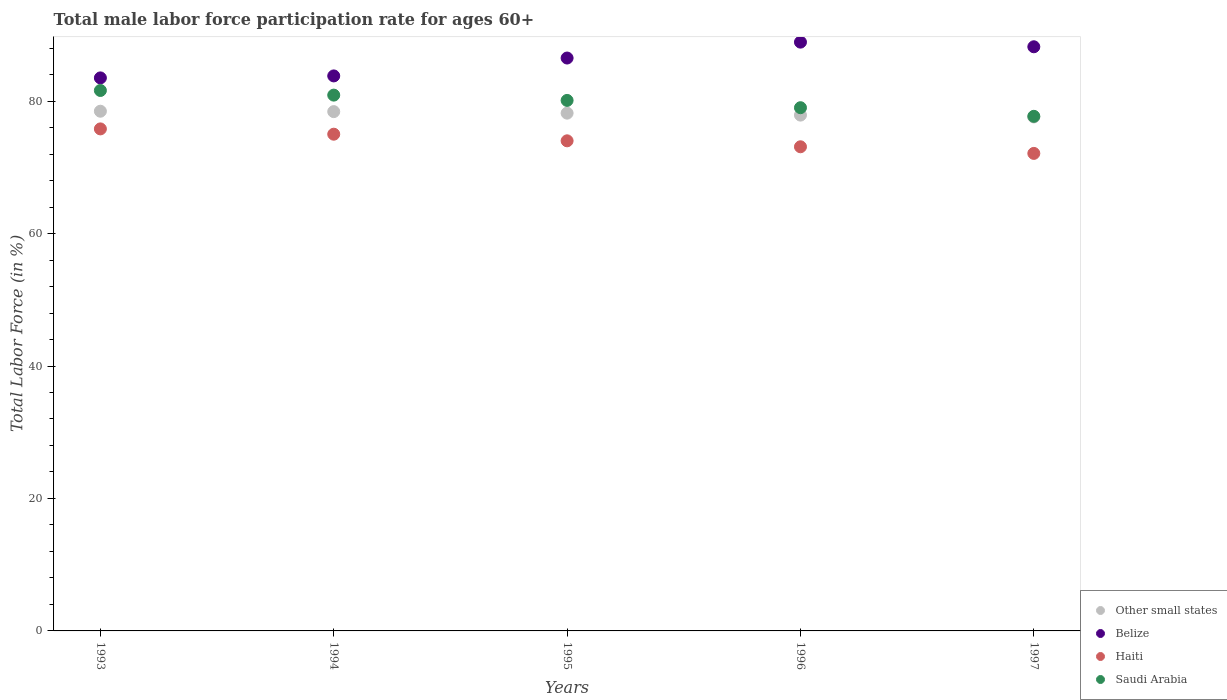What is the male labor force participation rate in Saudi Arabia in 1993?
Offer a terse response. 81.6. Across all years, what is the maximum male labor force participation rate in Belize?
Ensure brevity in your answer.  88.9. Across all years, what is the minimum male labor force participation rate in Saudi Arabia?
Your response must be concise. 77.7. In which year was the male labor force participation rate in Other small states minimum?
Your response must be concise. 1997. What is the total male labor force participation rate in Haiti in the graph?
Your answer should be compact. 370. What is the difference between the male labor force participation rate in Saudi Arabia in 1993 and that in 1997?
Offer a terse response. 3.9. What is the difference between the male labor force participation rate in Saudi Arabia in 1993 and the male labor force participation rate in Belize in 1994?
Your answer should be compact. -2.2. What is the average male labor force participation rate in Belize per year?
Ensure brevity in your answer.  86.18. In the year 1994, what is the difference between the male labor force participation rate in Belize and male labor force participation rate in Saudi Arabia?
Your response must be concise. 2.9. What is the ratio of the male labor force participation rate in Other small states in 1995 to that in 1997?
Keep it short and to the point. 1.01. Is the male labor force participation rate in Belize in 1994 less than that in 1995?
Your response must be concise. Yes. Is the difference between the male labor force participation rate in Belize in 1993 and 1995 greater than the difference between the male labor force participation rate in Saudi Arabia in 1993 and 1995?
Provide a short and direct response. No. What is the difference between the highest and the second highest male labor force participation rate in Belize?
Your response must be concise. 0.7. What is the difference between the highest and the lowest male labor force participation rate in Saudi Arabia?
Provide a succinct answer. 3.9. In how many years, is the male labor force participation rate in Belize greater than the average male labor force participation rate in Belize taken over all years?
Your answer should be very brief. 3. Is the sum of the male labor force participation rate in Saudi Arabia in 1993 and 1996 greater than the maximum male labor force participation rate in Haiti across all years?
Your answer should be compact. Yes. Is it the case that in every year, the sum of the male labor force participation rate in Haiti and male labor force participation rate in Saudi Arabia  is greater than the sum of male labor force participation rate in Belize and male labor force participation rate in Other small states?
Ensure brevity in your answer.  No. Is the male labor force participation rate in Saudi Arabia strictly less than the male labor force participation rate in Other small states over the years?
Make the answer very short. No. How many dotlines are there?
Offer a terse response. 4. Does the graph contain any zero values?
Offer a terse response. No. Does the graph contain grids?
Offer a terse response. No. Where does the legend appear in the graph?
Provide a succinct answer. Bottom right. How many legend labels are there?
Ensure brevity in your answer.  4. What is the title of the graph?
Ensure brevity in your answer.  Total male labor force participation rate for ages 60+. Does "Tuvalu" appear as one of the legend labels in the graph?
Offer a very short reply. No. What is the label or title of the X-axis?
Your answer should be compact. Years. What is the Total Labor Force (in %) of Other small states in 1993?
Your answer should be very brief. 78.47. What is the Total Labor Force (in %) of Belize in 1993?
Your answer should be compact. 83.5. What is the Total Labor Force (in %) of Haiti in 1993?
Offer a terse response. 75.8. What is the Total Labor Force (in %) of Saudi Arabia in 1993?
Make the answer very short. 81.6. What is the Total Labor Force (in %) of Other small states in 1994?
Offer a very short reply. 78.41. What is the Total Labor Force (in %) of Belize in 1994?
Your response must be concise. 83.8. What is the Total Labor Force (in %) of Saudi Arabia in 1994?
Provide a short and direct response. 80.9. What is the Total Labor Force (in %) of Other small states in 1995?
Give a very brief answer. 78.18. What is the Total Labor Force (in %) in Belize in 1995?
Offer a very short reply. 86.5. What is the Total Labor Force (in %) of Haiti in 1995?
Provide a short and direct response. 74. What is the Total Labor Force (in %) of Saudi Arabia in 1995?
Your answer should be compact. 80.1. What is the Total Labor Force (in %) in Other small states in 1996?
Provide a short and direct response. 77.88. What is the Total Labor Force (in %) of Belize in 1996?
Offer a terse response. 88.9. What is the Total Labor Force (in %) in Haiti in 1996?
Your response must be concise. 73.1. What is the Total Labor Force (in %) in Saudi Arabia in 1996?
Offer a very short reply. 79. What is the Total Labor Force (in %) of Other small states in 1997?
Offer a very short reply. 77.6. What is the Total Labor Force (in %) in Belize in 1997?
Make the answer very short. 88.2. What is the Total Labor Force (in %) of Haiti in 1997?
Your response must be concise. 72.1. What is the Total Labor Force (in %) in Saudi Arabia in 1997?
Offer a terse response. 77.7. Across all years, what is the maximum Total Labor Force (in %) in Other small states?
Offer a terse response. 78.47. Across all years, what is the maximum Total Labor Force (in %) in Belize?
Ensure brevity in your answer.  88.9. Across all years, what is the maximum Total Labor Force (in %) in Haiti?
Ensure brevity in your answer.  75.8. Across all years, what is the maximum Total Labor Force (in %) of Saudi Arabia?
Your answer should be compact. 81.6. Across all years, what is the minimum Total Labor Force (in %) in Other small states?
Make the answer very short. 77.6. Across all years, what is the minimum Total Labor Force (in %) of Belize?
Your answer should be very brief. 83.5. Across all years, what is the minimum Total Labor Force (in %) in Haiti?
Offer a terse response. 72.1. Across all years, what is the minimum Total Labor Force (in %) of Saudi Arabia?
Ensure brevity in your answer.  77.7. What is the total Total Labor Force (in %) of Other small states in the graph?
Provide a short and direct response. 390.54. What is the total Total Labor Force (in %) of Belize in the graph?
Give a very brief answer. 430.9. What is the total Total Labor Force (in %) of Haiti in the graph?
Your answer should be very brief. 370. What is the total Total Labor Force (in %) of Saudi Arabia in the graph?
Offer a very short reply. 399.3. What is the difference between the Total Labor Force (in %) in Other small states in 1993 and that in 1994?
Make the answer very short. 0.06. What is the difference between the Total Labor Force (in %) of Saudi Arabia in 1993 and that in 1994?
Provide a short and direct response. 0.7. What is the difference between the Total Labor Force (in %) in Other small states in 1993 and that in 1995?
Your answer should be very brief. 0.29. What is the difference between the Total Labor Force (in %) of Belize in 1993 and that in 1995?
Your response must be concise. -3. What is the difference between the Total Labor Force (in %) of Saudi Arabia in 1993 and that in 1995?
Give a very brief answer. 1.5. What is the difference between the Total Labor Force (in %) of Other small states in 1993 and that in 1996?
Your answer should be very brief. 0.59. What is the difference between the Total Labor Force (in %) of Haiti in 1993 and that in 1996?
Your answer should be compact. 2.7. What is the difference between the Total Labor Force (in %) in Saudi Arabia in 1993 and that in 1996?
Your answer should be very brief. 2.6. What is the difference between the Total Labor Force (in %) in Other small states in 1993 and that in 1997?
Ensure brevity in your answer.  0.87. What is the difference between the Total Labor Force (in %) in Belize in 1993 and that in 1997?
Offer a very short reply. -4.7. What is the difference between the Total Labor Force (in %) in Other small states in 1994 and that in 1995?
Give a very brief answer. 0.23. What is the difference between the Total Labor Force (in %) in Belize in 1994 and that in 1995?
Provide a short and direct response. -2.7. What is the difference between the Total Labor Force (in %) in Haiti in 1994 and that in 1995?
Provide a succinct answer. 1. What is the difference between the Total Labor Force (in %) of Other small states in 1994 and that in 1996?
Your response must be concise. 0.53. What is the difference between the Total Labor Force (in %) of Haiti in 1994 and that in 1996?
Provide a succinct answer. 1.9. What is the difference between the Total Labor Force (in %) in Other small states in 1994 and that in 1997?
Your response must be concise. 0.81. What is the difference between the Total Labor Force (in %) in Saudi Arabia in 1994 and that in 1997?
Offer a very short reply. 3.2. What is the difference between the Total Labor Force (in %) in Other small states in 1995 and that in 1996?
Your answer should be compact. 0.3. What is the difference between the Total Labor Force (in %) of Saudi Arabia in 1995 and that in 1996?
Offer a very short reply. 1.1. What is the difference between the Total Labor Force (in %) of Other small states in 1995 and that in 1997?
Your answer should be very brief. 0.58. What is the difference between the Total Labor Force (in %) in Belize in 1995 and that in 1997?
Offer a very short reply. -1.7. What is the difference between the Total Labor Force (in %) of Haiti in 1995 and that in 1997?
Provide a short and direct response. 1.9. What is the difference between the Total Labor Force (in %) of Saudi Arabia in 1995 and that in 1997?
Offer a very short reply. 2.4. What is the difference between the Total Labor Force (in %) in Other small states in 1996 and that in 1997?
Provide a short and direct response. 0.28. What is the difference between the Total Labor Force (in %) of Other small states in 1993 and the Total Labor Force (in %) of Belize in 1994?
Give a very brief answer. -5.33. What is the difference between the Total Labor Force (in %) of Other small states in 1993 and the Total Labor Force (in %) of Haiti in 1994?
Offer a terse response. 3.47. What is the difference between the Total Labor Force (in %) of Other small states in 1993 and the Total Labor Force (in %) of Saudi Arabia in 1994?
Make the answer very short. -2.43. What is the difference between the Total Labor Force (in %) of Belize in 1993 and the Total Labor Force (in %) of Saudi Arabia in 1994?
Your answer should be compact. 2.6. What is the difference between the Total Labor Force (in %) in Other small states in 1993 and the Total Labor Force (in %) in Belize in 1995?
Give a very brief answer. -8.03. What is the difference between the Total Labor Force (in %) of Other small states in 1993 and the Total Labor Force (in %) of Haiti in 1995?
Offer a very short reply. 4.47. What is the difference between the Total Labor Force (in %) in Other small states in 1993 and the Total Labor Force (in %) in Saudi Arabia in 1995?
Offer a very short reply. -1.63. What is the difference between the Total Labor Force (in %) in Belize in 1993 and the Total Labor Force (in %) in Saudi Arabia in 1995?
Ensure brevity in your answer.  3.4. What is the difference between the Total Labor Force (in %) of Haiti in 1993 and the Total Labor Force (in %) of Saudi Arabia in 1995?
Give a very brief answer. -4.3. What is the difference between the Total Labor Force (in %) in Other small states in 1993 and the Total Labor Force (in %) in Belize in 1996?
Keep it short and to the point. -10.43. What is the difference between the Total Labor Force (in %) of Other small states in 1993 and the Total Labor Force (in %) of Haiti in 1996?
Make the answer very short. 5.37. What is the difference between the Total Labor Force (in %) in Other small states in 1993 and the Total Labor Force (in %) in Saudi Arabia in 1996?
Provide a short and direct response. -0.53. What is the difference between the Total Labor Force (in %) of Other small states in 1993 and the Total Labor Force (in %) of Belize in 1997?
Give a very brief answer. -9.73. What is the difference between the Total Labor Force (in %) in Other small states in 1993 and the Total Labor Force (in %) in Haiti in 1997?
Ensure brevity in your answer.  6.37. What is the difference between the Total Labor Force (in %) in Other small states in 1993 and the Total Labor Force (in %) in Saudi Arabia in 1997?
Offer a terse response. 0.77. What is the difference between the Total Labor Force (in %) in Belize in 1993 and the Total Labor Force (in %) in Haiti in 1997?
Offer a terse response. 11.4. What is the difference between the Total Labor Force (in %) of Other small states in 1994 and the Total Labor Force (in %) of Belize in 1995?
Provide a succinct answer. -8.09. What is the difference between the Total Labor Force (in %) of Other small states in 1994 and the Total Labor Force (in %) of Haiti in 1995?
Your answer should be very brief. 4.41. What is the difference between the Total Labor Force (in %) in Other small states in 1994 and the Total Labor Force (in %) in Saudi Arabia in 1995?
Provide a succinct answer. -1.69. What is the difference between the Total Labor Force (in %) of Belize in 1994 and the Total Labor Force (in %) of Haiti in 1995?
Give a very brief answer. 9.8. What is the difference between the Total Labor Force (in %) in Belize in 1994 and the Total Labor Force (in %) in Saudi Arabia in 1995?
Provide a short and direct response. 3.7. What is the difference between the Total Labor Force (in %) in Other small states in 1994 and the Total Labor Force (in %) in Belize in 1996?
Ensure brevity in your answer.  -10.49. What is the difference between the Total Labor Force (in %) of Other small states in 1994 and the Total Labor Force (in %) of Haiti in 1996?
Make the answer very short. 5.31. What is the difference between the Total Labor Force (in %) of Other small states in 1994 and the Total Labor Force (in %) of Saudi Arabia in 1996?
Keep it short and to the point. -0.59. What is the difference between the Total Labor Force (in %) of Belize in 1994 and the Total Labor Force (in %) of Saudi Arabia in 1996?
Ensure brevity in your answer.  4.8. What is the difference between the Total Labor Force (in %) of Other small states in 1994 and the Total Labor Force (in %) of Belize in 1997?
Ensure brevity in your answer.  -9.79. What is the difference between the Total Labor Force (in %) in Other small states in 1994 and the Total Labor Force (in %) in Haiti in 1997?
Keep it short and to the point. 6.31. What is the difference between the Total Labor Force (in %) in Other small states in 1994 and the Total Labor Force (in %) in Saudi Arabia in 1997?
Keep it short and to the point. 0.71. What is the difference between the Total Labor Force (in %) of Belize in 1994 and the Total Labor Force (in %) of Haiti in 1997?
Your response must be concise. 11.7. What is the difference between the Total Labor Force (in %) in Belize in 1994 and the Total Labor Force (in %) in Saudi Arabia in 1997?
Provide a short and direct response. 6.1. What is the difference between the Total Labor Force (in %) in Other small states in 1995 and the Total Labor Force (in %) in Belize in 1996?
Your answer should be compact. -10.72. What is the difference between the Total Labor Force (in %) in Other small states in 1995 and the Total Labor Force (in %) in Haiti in 1996?
Your response must be concise. 5.08. What is the difference between the Total Labor Force (in %) in Other small states in 1995 and the Total Labor Force (in %) in Saudi Arabia in 1996?
Offer a terse response. -0.82. What is the difference between the Total Labor Force (in %) in Belize in 1995 and the Total Labor Force (in %) in Haiti in 1996?
Your response must be concise. 13.4. What is the difference between the Total Labor Force (in %) in Other small states in 1995 and the Total Labor Force (in %) in Belize in 1997?
Make the answer very short. -10.02. What is the difference between the Total Labor Force (in %) of Other small states in 1995 and the Total Labor Force (in %) of Haiti in 1997?
Keep it short and to the point. 6.08. What is the difference between the Total Labor Force (in %) in Other small states in 1995 and the Total Labor Force (in %) in Saudi Arabia in 1997?
Make the answer very short. 0.48. What is the difference between the Total Labor Force (in %) of Belize in 1995 and the Total Labor Force (in %) of Haiti in 1997?
Your response must be concise. 14.4. What is the difference between the Total Labor Force (in %) in Other small states in 1996 and the Total Labor Force (in %) in Belize in 1997?
Your answer should be compact. -10.32. What is the difference between the Total Labor Force (in %) in Other small states in 1996 and the Total Labor Force (in %) in Haiti in 1997?
Your answer should be compact. 5.78. What is the difference between the Total Labor Force (in %) in Other small states in 1996 and the Total Labor Force (in %) in Saudi Arabia in 1997?
Offer a very short reply. 0.18. What is the difference between the Total Labor Force (in %) in Belize in 1996 and the Total Labor Force (in %) in Saudi Arabia in 1997?
Your response must be concise. 11.2. What is the difference between the Total Labor Force (in %) in Haiti in 1996 and the Total Labor Force (in %) in Saudi Arabia in 1997?
Provide a succinct answer. -4.6. What is the average Total Labor Force (in %) of Other small states per year?
Keep it short and to the point. 78.11. What is the average Total Labor Force (in %) in Belize per year?
Offer a terse response. 86.18. What is the average Total Labor Force (in %) of Haiti per year?
Offer a very short reply. 74. What is the average Total Labor Force (in %) in Saudi Arabia per year?
Give a very brief answer. 79.86. In the year 1993, what is the difference between the Total Labor Force (in %) of Other small states and Total Labor Force (in %) of Belize?
Keep it short and to the point. -5.03. In the year 1993, what is the difference between the Total Labor Force (in %) in Other small states and Total Labor Force (in %) in Haiti?
Provide a succinct answer. 2.67. In the year 1993, what is the difference between the Total Labor Force (in %) of Other small states and Total Labor Force (in %) of Saudi Arabia?
Provide a short and direct response. -3.13. In the year 1993, what is the difference between the Total Labor Force (in %) in Belize and Total Labor Force (in %) in Haiti?
Ensure brevity in your answer.  7.7. In the year 1993, what is the difference between the Total Labor Force (in %) of Belize and Total Labor Force (in %) of Saudi Arabia?
Keep it short and to the point. 1.9. In the year 1994, what is the difference between the Total Labor Force (in %) in Other small states and Total Labor Force (in %) in Belize?
Keep it short and to the point. -5.39. In the year 1994, what is the difference between the Total Labor Force (in %) in Other small states and Total Labor Force (in %) in Haiti?
Give a very brief answer. 3.41. In the year 1994, what is the difference between the Total Labor Force (in %) in Other small states and Total Labor Force (in %) in Saudi Arabia?
Ensure brevity in your answer.  -2.49. In the year 1994, what is the difference between the Total Labor Force (in %) in Haiti and Total Labor Force (in %) in Saudi Arabia?
Make the answer very short. -5.9. In the year 1995, what is the difference between the Total Labor Force (in %) of Other small states and Total Labor Force (in %) of Belize?
Offer a very short reply. -8.32. In the year 1995, what is the difference between the Total Labor Force (in %) of Other small states and Total Labor Force (in %) of Haiti?
Make the answer very short. 4.18. In the year 1995, what is the difference between the Total Labor Force (in %) of Other small states and Total Labor Force (in %) of Saudi Arabia?
Your answer should be compact. -1.92. In the year 1995, what is the difference between the Total Labor Force (in %) of Belize and Total Labor Force (in %) of Haiti?
Ensure brevity in your answer.  12.5. In the year 1996, what is the difference between the Total Labor Force (in %) of Other small states and Total Labor Force (in %) of Belize?
Your response must be concise. -11.02. In the year 1996, what is the difference between the Total Labor Force (in %) in Other small states and Total Labor Force (in %) in Haiti?
Ensure brevity in your answer.  4.78. In the year 1996, what is the difference between the Total Labor Force (in %) in Other small states and Total Labor Force (in %) in Saudi Arabia?
Offer a very short reply. -1.12. In the year 1996, what is the difference between the Total Labor Force (in %) of Belize and Total Labor Force (in %) of Haiti?
Keep it short and to the point. 15.8. In the year 1996, what is the difference between the Total Labor Force (in %) of Belize and Total Labor Force (in %) of Saudi Arabia?
Your response must be concise. 9.9. In the year 1997, what is the difference between the Total Labor Force (in %) of Other small states and Total Labor Force (in %) of Belize?
Provide a succinct answer. -10.6. In the year 1997, what is the difference between the Total Labor Force (in %) of Other small states and Total Labor Force (in %) of Haiti?
Your response must be concise. 5.5. In the year 1997, what is the difference between the Total Labor Force (in %) of Other small states and Total Labor Force (in %) of Saudi Arabia?
Provide a short and direct response. -0.1. In the year 1997, what is the difference between the Total Labor Force (in %) in Belize and Total Labor Force (in %) in Haiti?
Offer a very short reply. 16.1. In the year 1997, what is the difference between the Total Labor Force (in %) of Belize and Total Labor Force (in %) of Saudi Arabia?
Provide a short and direct response. 10.5. What is the ratio of the Total Labor Force (in %) in Other small states in 1993 to that in 1994?
Your response must be concise. 1. What is the ratio of the Total Labor Force (in %) in Haiti in 1993 to that in 1994?
Your response must be concise. 1.01. What is the ratio of the Total Labor Force (in %) in Saudi Arabia in 1993 to that in 1994?
Make the answer very short. 1.01. What is the ratio of the Total Labor Force (in %) in Other small states in 1993 to that in 1995?
Give a very brief answer. 1. What is the ratio of the Total Labor Force (in %) in Belize in 1993 to that in 1995?
Offer a terse response. 0.97. What is the ratio of the Total Labor Force (in %) of Haiti in 1993 to that in 1995?
Keep it short and to the point. 1.02. What is the ratio of the Total Labor Force (in %) of Saudi Arabia in 1993 to that in 1995?
Ensure brevity in your answer.  1.02. What is the ratio of the Total Labor Force (in %) in Other small states in 1993 to that in 1996?
Offer a terse response. 1.01. What is the ratio of the Total Labor Force (in %) of Belize in 1993 to that in 1996?
Ensure brevity in your answer.  0.94. What is the ratio of the Total Labor Force (in %) of Haiti in 1993 to that in 1996?
Offer a very short reply. 1.04. What is the ratio of the Total Labor Force (in %) of Saudi Arabia in 1993 to that in 1996?
Provide a succinct answer. 1.03. What is the ratio of the Total Labor Force (in %) in Other small states in 1993 to that in 1997?
Ensure brevity in your answer.  1.01. What is the ratio of the Total Labor Force (in %) in Belize in 1993 to that in 1997?
Provide a short and direct response. 0.95. What is the ratio of the Total Labor Force (in %) in Haiti in 1993 to that in 1997?
Your answer should be very brief. 1.05. What is the ratio of the Total Labor Force (in %) in Saudi Arabia in 1993 to that in 1997?
Make the answer very short. 1.05. What is the ratio of the Total Labor Force (in %) in Belize in 1994 to that in 1995?
Offer a terse response. 0.97. What is the ratio of the Total Labor Force (in %) of Haiti in 1994 to that in 1995?
Your answer should be very brief. 1.01. What is the ratio of the Total Labor Force (in %) in Other small states in 1994 to that in 1996?
Make the answer very short. 1.01. What is the ratio of the Total Labor Force (in %) of Belize in 1994 to that in 1996?
Offer a very short reply. 0.94. What is the ratio of the Total Labor Force (in %) in Haiti in 1994 to that in 1996?
Offer a very short reply. 1.03. What is the ratio of the Total Labor Force (in %) of Saudi Arabia in 1994 to that in 1996?
Your answer should be compact. 1.02. What is the ratio of the Total Labor Force (in %) in Other small states in 1994 to that in 1997?
Provide a succinct answer. 1.01. What is the ratio of the Total Labor Force (in %) in Belize in 1994 to that in 1997?
Your answer should be compact. 0.95. What is the ratio of the Total Labor Force (in %) of Haiti in 1994 to that in 1997?
Make the answer very short. 1.04. What is the ratio of the Total Labor Force (in %) of Saudi Arabia in 1994 to that in 1997?
Your answer should be very brief. 1.04. What is the ratio of the Total Labor Force (in %) in Belize in 1995 to that in 1996?
Keep it short and to the point. 0.97. What is the ratio of the Total Labor Force (in %) of Haiti in 1995 to that in 1996?
Make the answer very short. 1.01. What is the ratio of the Total Labor Force (in %) of Saudi Arabia in 1995 to that in 1996?
Offer a very short reply. 1.01. What is the ratio of the Total Labor Force (in %) of Other small states in 1995 to that in 1997?
Provide a succinct answer. 1.01. What is the ratio of the Total Labor Force (in %) of Belize in 1995 to that in 1997?
Offer a terse response. 0.98. What is the ratio of the Total Labor Force (in %) in Haiti in 1995 to that in 1997?
Keep it short and to the point. 1.03. What is the ratio of the Total Labor Force (in %) in Saudi Arabia in 1995 to that in 1997?
Give a very brief answer. 1.03. What is the ratio of the Total Labor Force (in %) in Other small states in 1996 to that in 1997?
Ensure brevity in your answer.  1. What is the ratio of the Total Labor Force (in %) of Belize in 1996 to that in 1997?
Provide a succinct answer. 1.01. What is the ratio of the Total Labor Force (in %) of Haiti in 1996 to that in 1997?
Give a very brief answer. 1.01. What is the ratio of the Total Labor Force (in %) in Saudi Arabia in 1996 to that in 1997?
Give a very brief answer. 1.02. What is the difference between the highest and the second highest Total Labor Force (in %) in Other small states?
Your answer should be very brief. 0.06. What is the difference between the highest and the second highest Total Labor Force (in %) in Belize?
Keep it short and to the point. 0.7. What is the difference between the highest and the lowest Total Labor Force (in %) in Other small states?
Ensure brevity in your answer.  0.87. 